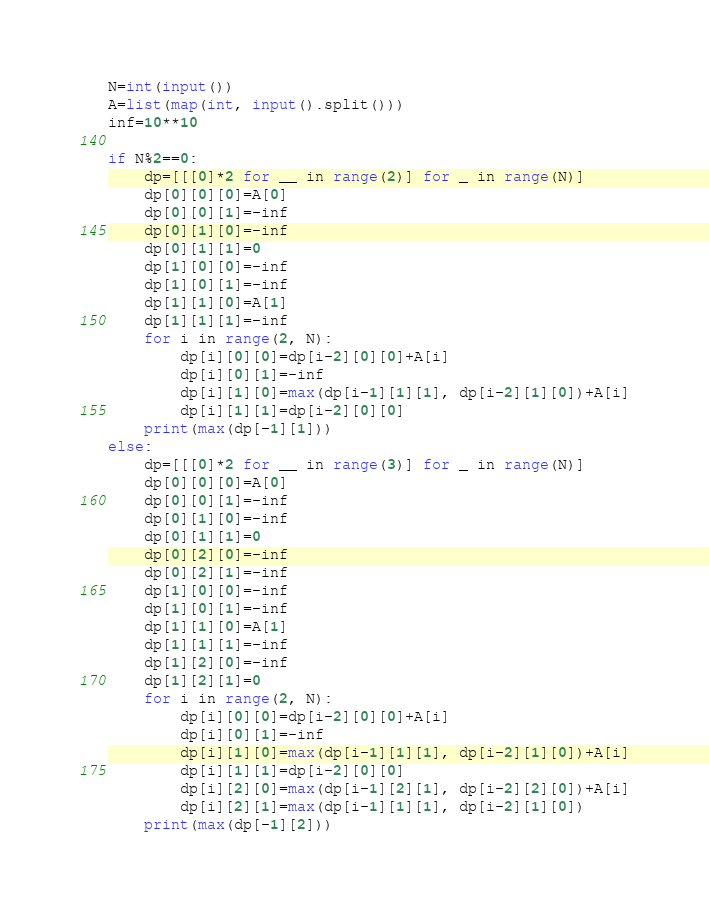Convert code to text. <code><loc_0><loc_0><loc_500><loc_500><_Python_>N=int(input())
A=list(map(int, input().split()))
inf=10**10

if N%2==0:
    dp=[[[0]*2 for __ in range(2)] for _ in range(N)]
    dp[0][0][0]=A[0]
    dp[0][0][1]=-inf
    dp[0][1][0]=-inf
    dp[0][1][1]=0
    dp[1][0][0]=-inf
    dp[1][0][1]=-inf
    dp[1][1][0]=A[1]
    dp[1][1][1]=-inf
    for i in range(2, N):
        dp[i][0][0]=dp[i-2][0][0]+A[i]
        dp[i][0][1]=-inf
        dp[i][1][0]=max(dp[i-1][1][1], dp[i-2][1][0])+A[i]
        dp[i][1][1]=dp[i-2][0][0]
    print(max(dp[-1][1]))
else:
    dp=[[[0]*2 for __ in range(3)] for _ in range(N)]
    dp[0][0][0]=A[0]
    dp[0][0][1]=-inf
    dp[0][1][0]=-inf
    dp[0][1][1]=0
    dp[0][2][0]=-inf
    dp[0][2][1]=-inf
    dp[1][0][0]=-inf
    dp[1][0][1]=-inf
    dp[1][1][0]=A[1]
    dp[1][1][1]=-inf
    dp[1][2][0]=-inf
    dp[1][2][1]=0
    for i in range(2, N):
        dp[i][0][0]=dp[i-2][0][0]+A[i]
        dp[i][0][1]=-inf
        dp[i][1][0]=max(dp[i-1][1][1], dp[i-2][1][0])+A[i]
        dp[i][1][1]=dp[i-2][0][0]
        dp[i][2][0]=max(dp[i-1][2][1], dp[i-2][2][0])+A[i]
        dp[i][2][1]=max(dp[i-1][1][1], dp[i-2][1][0])
    print(max(dp[-1][2]))</code> 